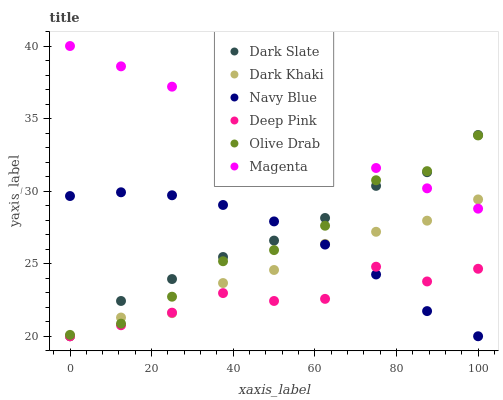Does Deep Pink have the minimum area under the curve?
Answer yes or no. Yes. Does Magenta have the maximum area under the curve?
Answer yes or no. Yes. Does Navy Blue have the minimum area under the curve?
Answer yes or no. No. Does Navy Blue have the maximum area under the curve?
Answer yes or no. No. Is Magenta the smoothest?
Answer yes or no. Yes. Is Deep Pink the roughest?
Answer yes or no. Yes. Is Navy Blue the smoothest?
Answer yes or no. No. Is Navy Blue the roughest?
Answer yes or no. No. Does Deep Pink have the lowest value?
Answer yes or no. Yes. Does Magenta have the lowest value?
Answer yes or no. No. Does Magenta have the highest value?
Answer yes or no. Yes. Does Navy Blue have the highest value?
Answer yes or no. No. Is Navy Blue less than Magenta?
Answer yes or no. Yes. Is Magenta greater than Navy Blue?
Answer yes or no. Yes. Does Navy Blue intersect Dark Khaki?
Answer yes or no. Yes. Is Navy Blue less than Dark Khaki?
Answer yes or no. No. Is Navy Blue greater than Dark Khaki?
Answer yes or no. No. Does Navy Blue intersect Magenta?
Answer yes or no. No. 